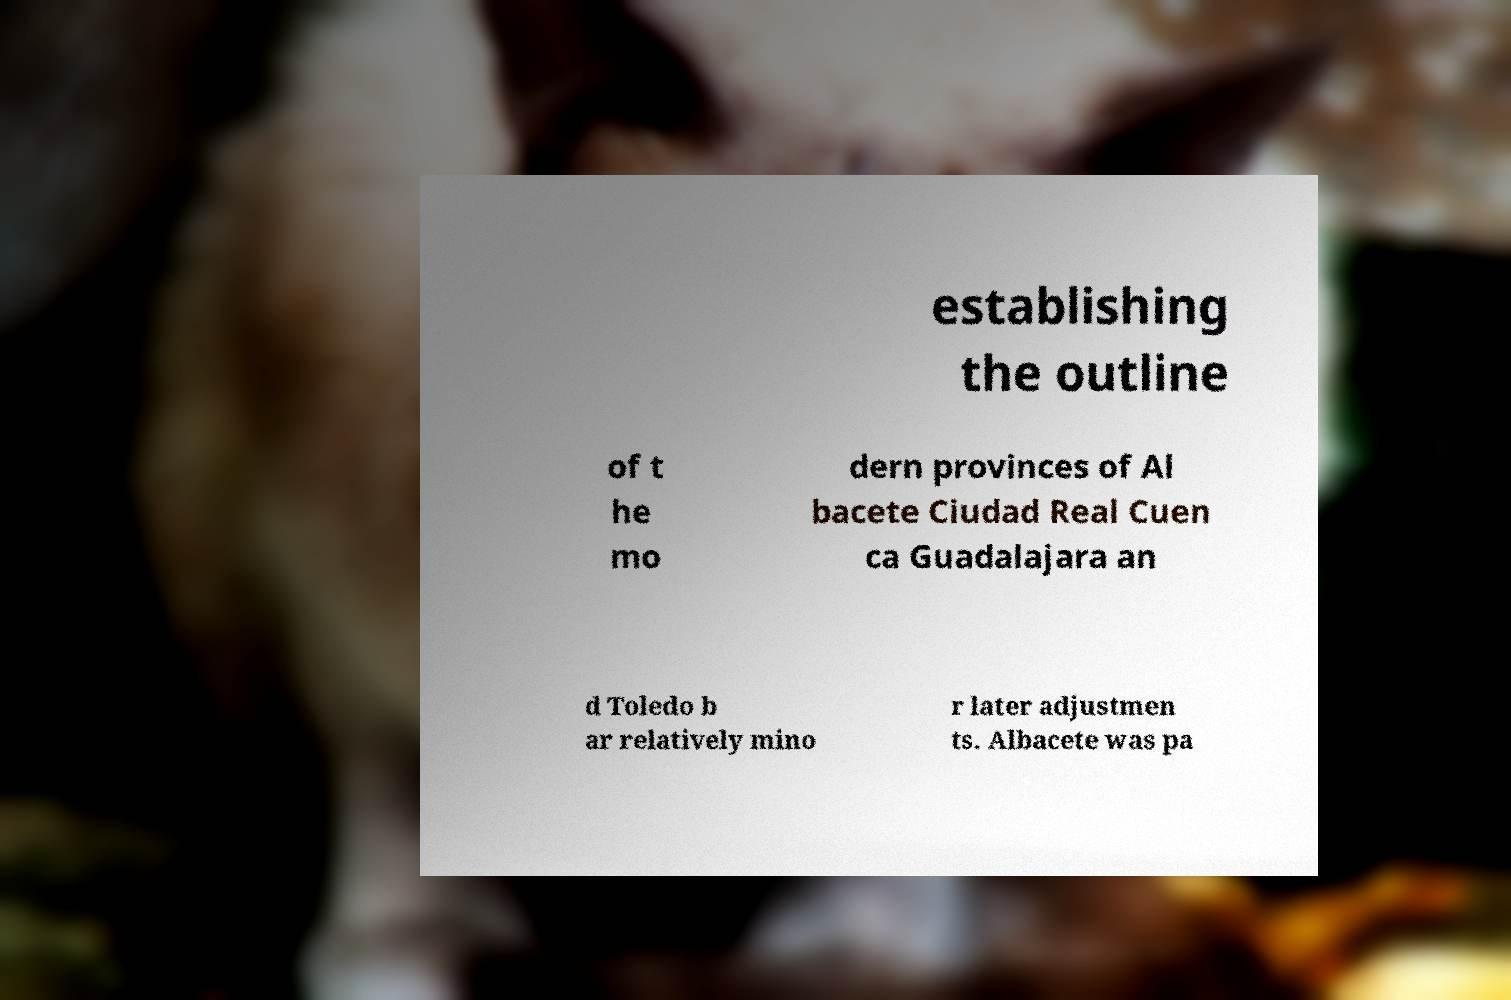There's text embedded in this image that I need extracted. Can you transcribe it verbatim? establishing the outline of t he mo dern provinces of Al bacete Ciudad Real Cuen ca Guadalajara an d Toledo b ar relatively mino r later adjustmen ts. Albacete was pa 